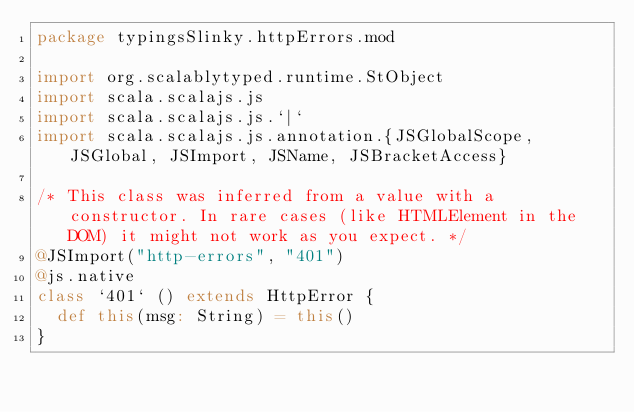<code> <loc_0><loc_0><loc_500><loc_500><_Scala_>package typingsSlinky.httpErrors.mod

import org.scalablytyped.runtime.StObject
import scala.scalajs.js
import scala.scalajs.js.`|`
import scala.scalajs.js.annotation.{JSGlobalScope, JSGlobal, JSImport, JSName, JSBracketAccess}

/* This class was inferred from a value with a constructor. In rare cases (like HTMLElement in the DOM) it might not work as you expect. */
@JSImport("http-errors", "401")
@js.native
class `401` () extends HttpError {
  def this(msg: String) = this()
}
</code> 